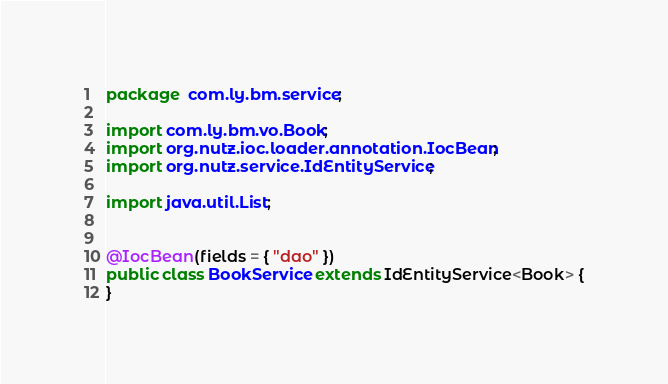<code> <loc_0><loc_0><loc_500><loc_500><_Java_>package  com.ly.bm.service;

import com.ly.bm.vo.Book;
import org.nutz.ioc.loader.annotation.IocBean;
import org.nutz.service.IdEntityService;

import java.util.List;


@IocBean(fields = { "dao" })
public class BookService extends IdEntityService<Book> {
}


</code> 